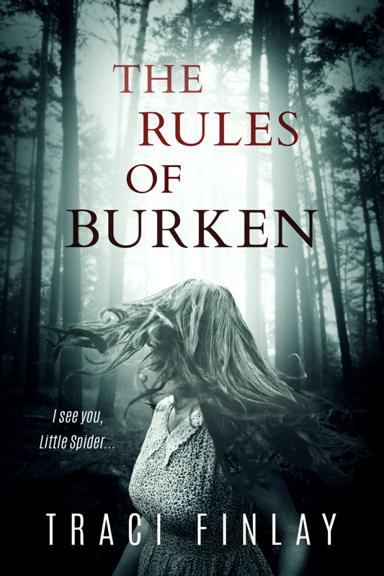What genre does the book 'The Rules of Burken' belong to, based on the cover? The book 'The Rules of Burken' appears to belong to the thriller or horror genre, suggested by the foreboding forest scene and misty environment depicted on the cover, typically indicative of suspense and mystery elements. 